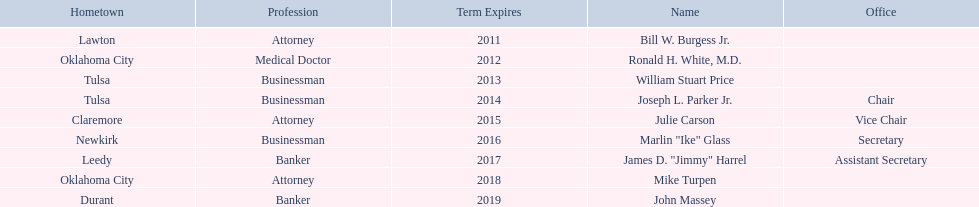How many of the current state regents will be in office until at least 2016? 4. 